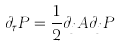Convert formula to latex. <formula><loc_0><loc_0><loc_500><loc_500>\partial _ { \tau } P = \frac { 1 } { 2 } \partial _ { j } A \partial _ { j } P</formula> 